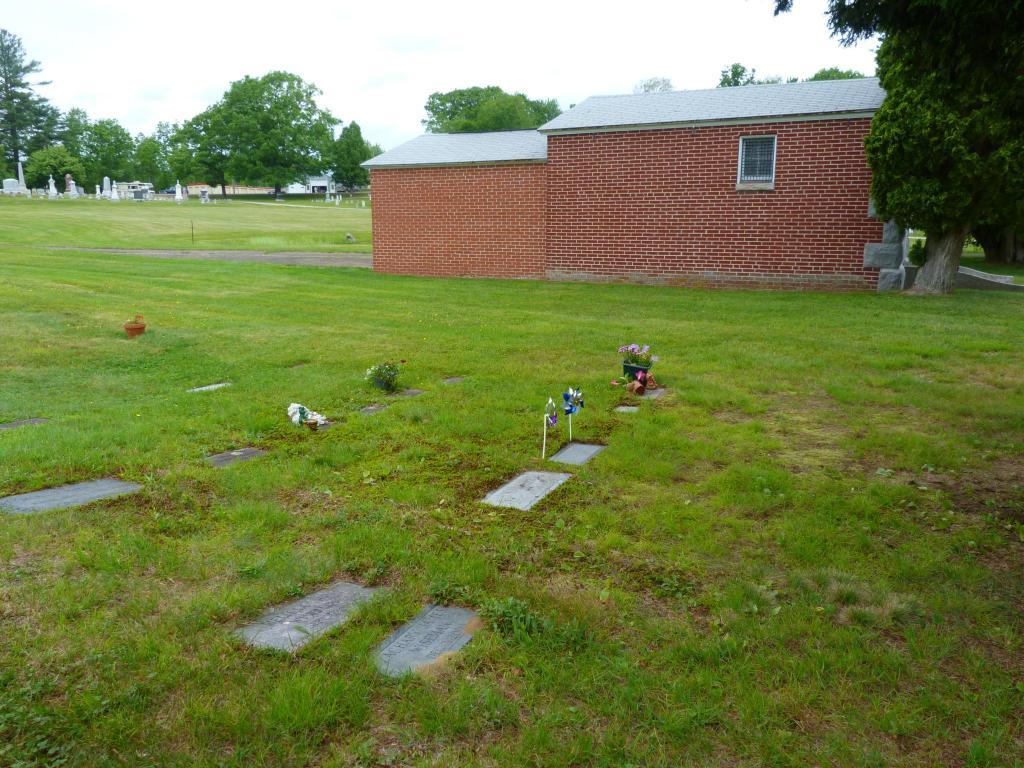What type of structure is present in the image? There is a house in the image. What is the color of the house? The house is brown in color. What type of vegetation can be seen in the image? There is grass and trees in the image. What is the color of the grass and trees? The grass and trees are green in color. What part of the natural environment is visible in the image? The sky is visible in the image. What is the color of the sky? The sky is white in color. What is the cause of the wealth depicted in the image? There is no depiction of wealth in the image; it features a brown house, green grass and trees, and a white sky. 